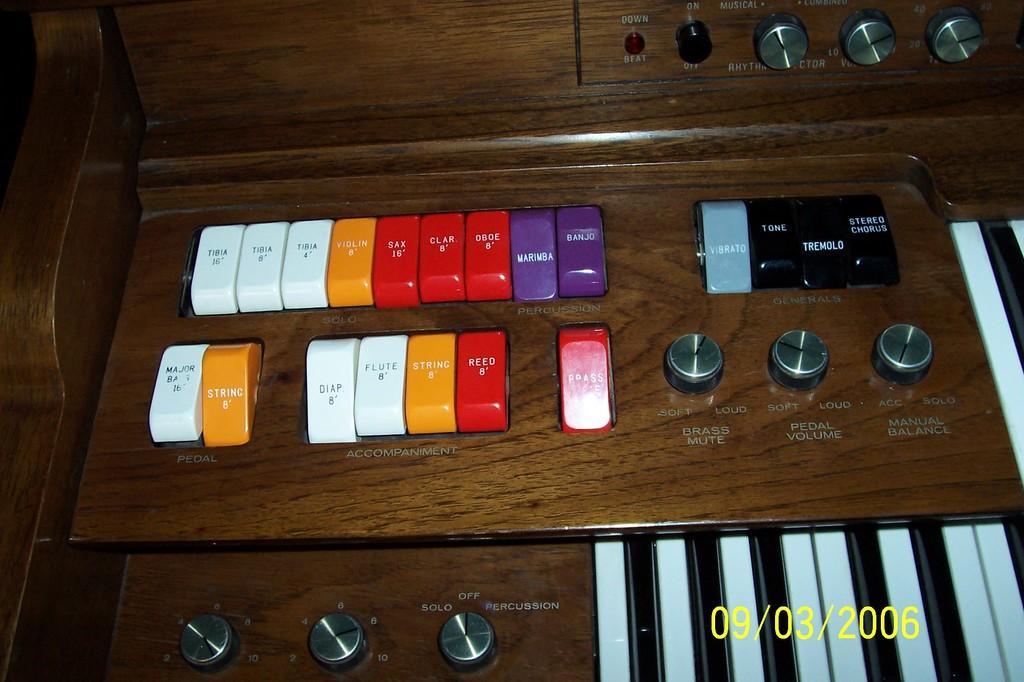Could you give a brief overview of what you see in this image? This is a keyboard. In this image we can see keys, rotators, switches, led light are present on the board. 